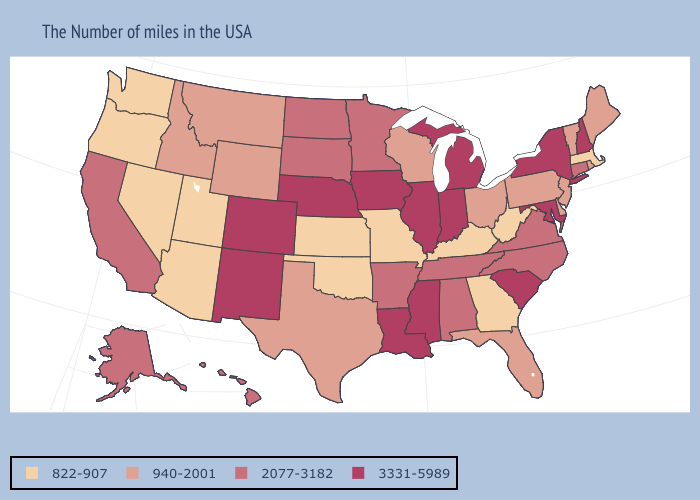What is the value of Rhode Island?
Keep it brief. 940-2001. Name the states that have a value in the range 2077-3182?
Be succinct. Connecticut, Virginia, North Carolina, Alabama, Tennessee, Arkansas, Minnesota, South Dakota, North Dakota, California, Alaska, Hawaii. What is the value of Maine?
Be succinct. 940-2001. Among the states that border Wisconsin , does Illinois have the lowest value?
Write a very short answer. No. What is the value of Colorado?
Quick response, please. 3331-5989. What is the value of Vermont?
Give a very brief answer. 940-2001. Which states have the highest value in the USA?
Write a very short answer. New Hampshire, New York, Maryland, South Carolina, Michigan, Indiana, Illinois, Mississippi, Louisiana, Iowa, Nebraska, Colorado, New Mexico. What is the value of Washington?
Give a very brief answer. 822-907. What is the lowest value in the USA?
Short answer required. 822-907. Name the states that have a value in the range 822-907?
Give a very brief answer. Massachusetts, West Virginia, Georgia, Kentucky, Missouri, Kansas, Oklahoma, Utah, Arizona, Nevada, Washington, Oregon. What is the value of Texas?
Keep it brief. 940-2001. What is the highest value in the West ?
Keep it brief. 3331-5989. Among the states that border South Carolina , which have the highest value?
Quick response, please. North Carolina. What is the value of Minnesota?
Answer briefly. 2077-3182. 